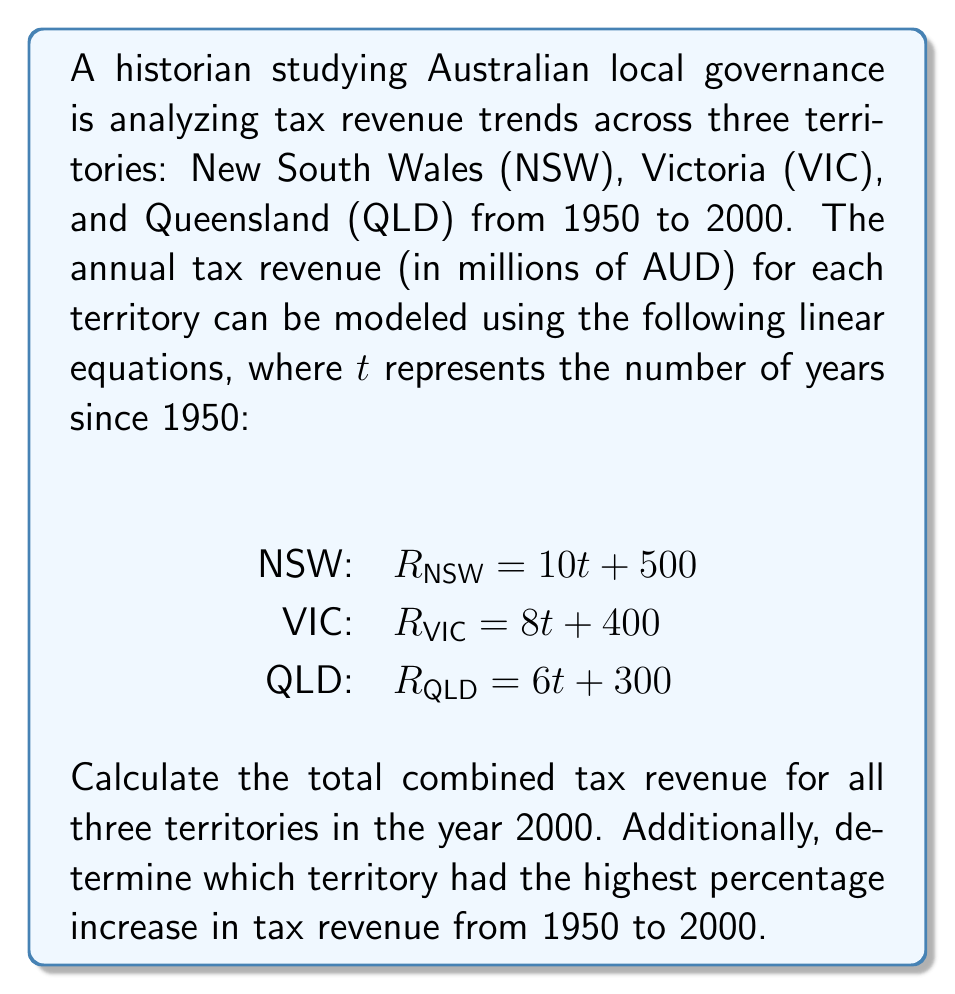Show me your answer to this math problem. To solve this problem, we'll follow these steps:

1. Calculate the tax revenue for each territory in 2000:
   The year 2000 is 50 years after 1950, so we'll use $t = 50$ in each equation.

   NSW: $R_{NSW} = 10(50) + 500 = 1000$
   VIC: $R_{VIC} = 8(50) + 400 = 800$
   QLD: $R_{QLD} = 6(50) + 300 = 600$

2. Sum the revenues to get the total combined tax revenue in 2000:
   $R_{total} = R_{NSW} + R_{VIC} + R_{QLD} = 1000 + 800 + 600 = 2400$ million AUD

3. Calculate the percentage increase for each territory:
   We need to find the revenue in 1950 ($t = 0$) and in 2000 ($t = 50$) for each territory.

   NSW:
   1950: $R_{NSW,1950} = 10(0) + 500 = 500$
   2000: $R_{NSW,2000} = 1000$
   Percentage increase: $\frac{1000 - 500}{500} \times 100\% = 100\%$

   VIC:
   1950: $R_{VIC,1950} = 8(0) + 400 = 400$
   2000: $R_{VIC,2000} = 800$
   Percentage increase: $\frac{800 - 400}{400} \times 100\% = 100\%$

   QLD:
   1950: $R_{QLD,1950} = 6(0) + 300 = 300$
   2000: $R_{QLD,2000} = 600$
   Percentage increase: $\frac{600 - 300}{300} \times 100\% = 100\%$

4. Compare the percentage increases:
   All three territories have the same percentage increase of 100%.
Answer: The total combined tax revenue for all three territories in the year 2000 is 2400 million AUD. All three territories (NSW, VIC, and QLD) had the same percentage increase of 100% in tax revenue from 1950 to 2000. 